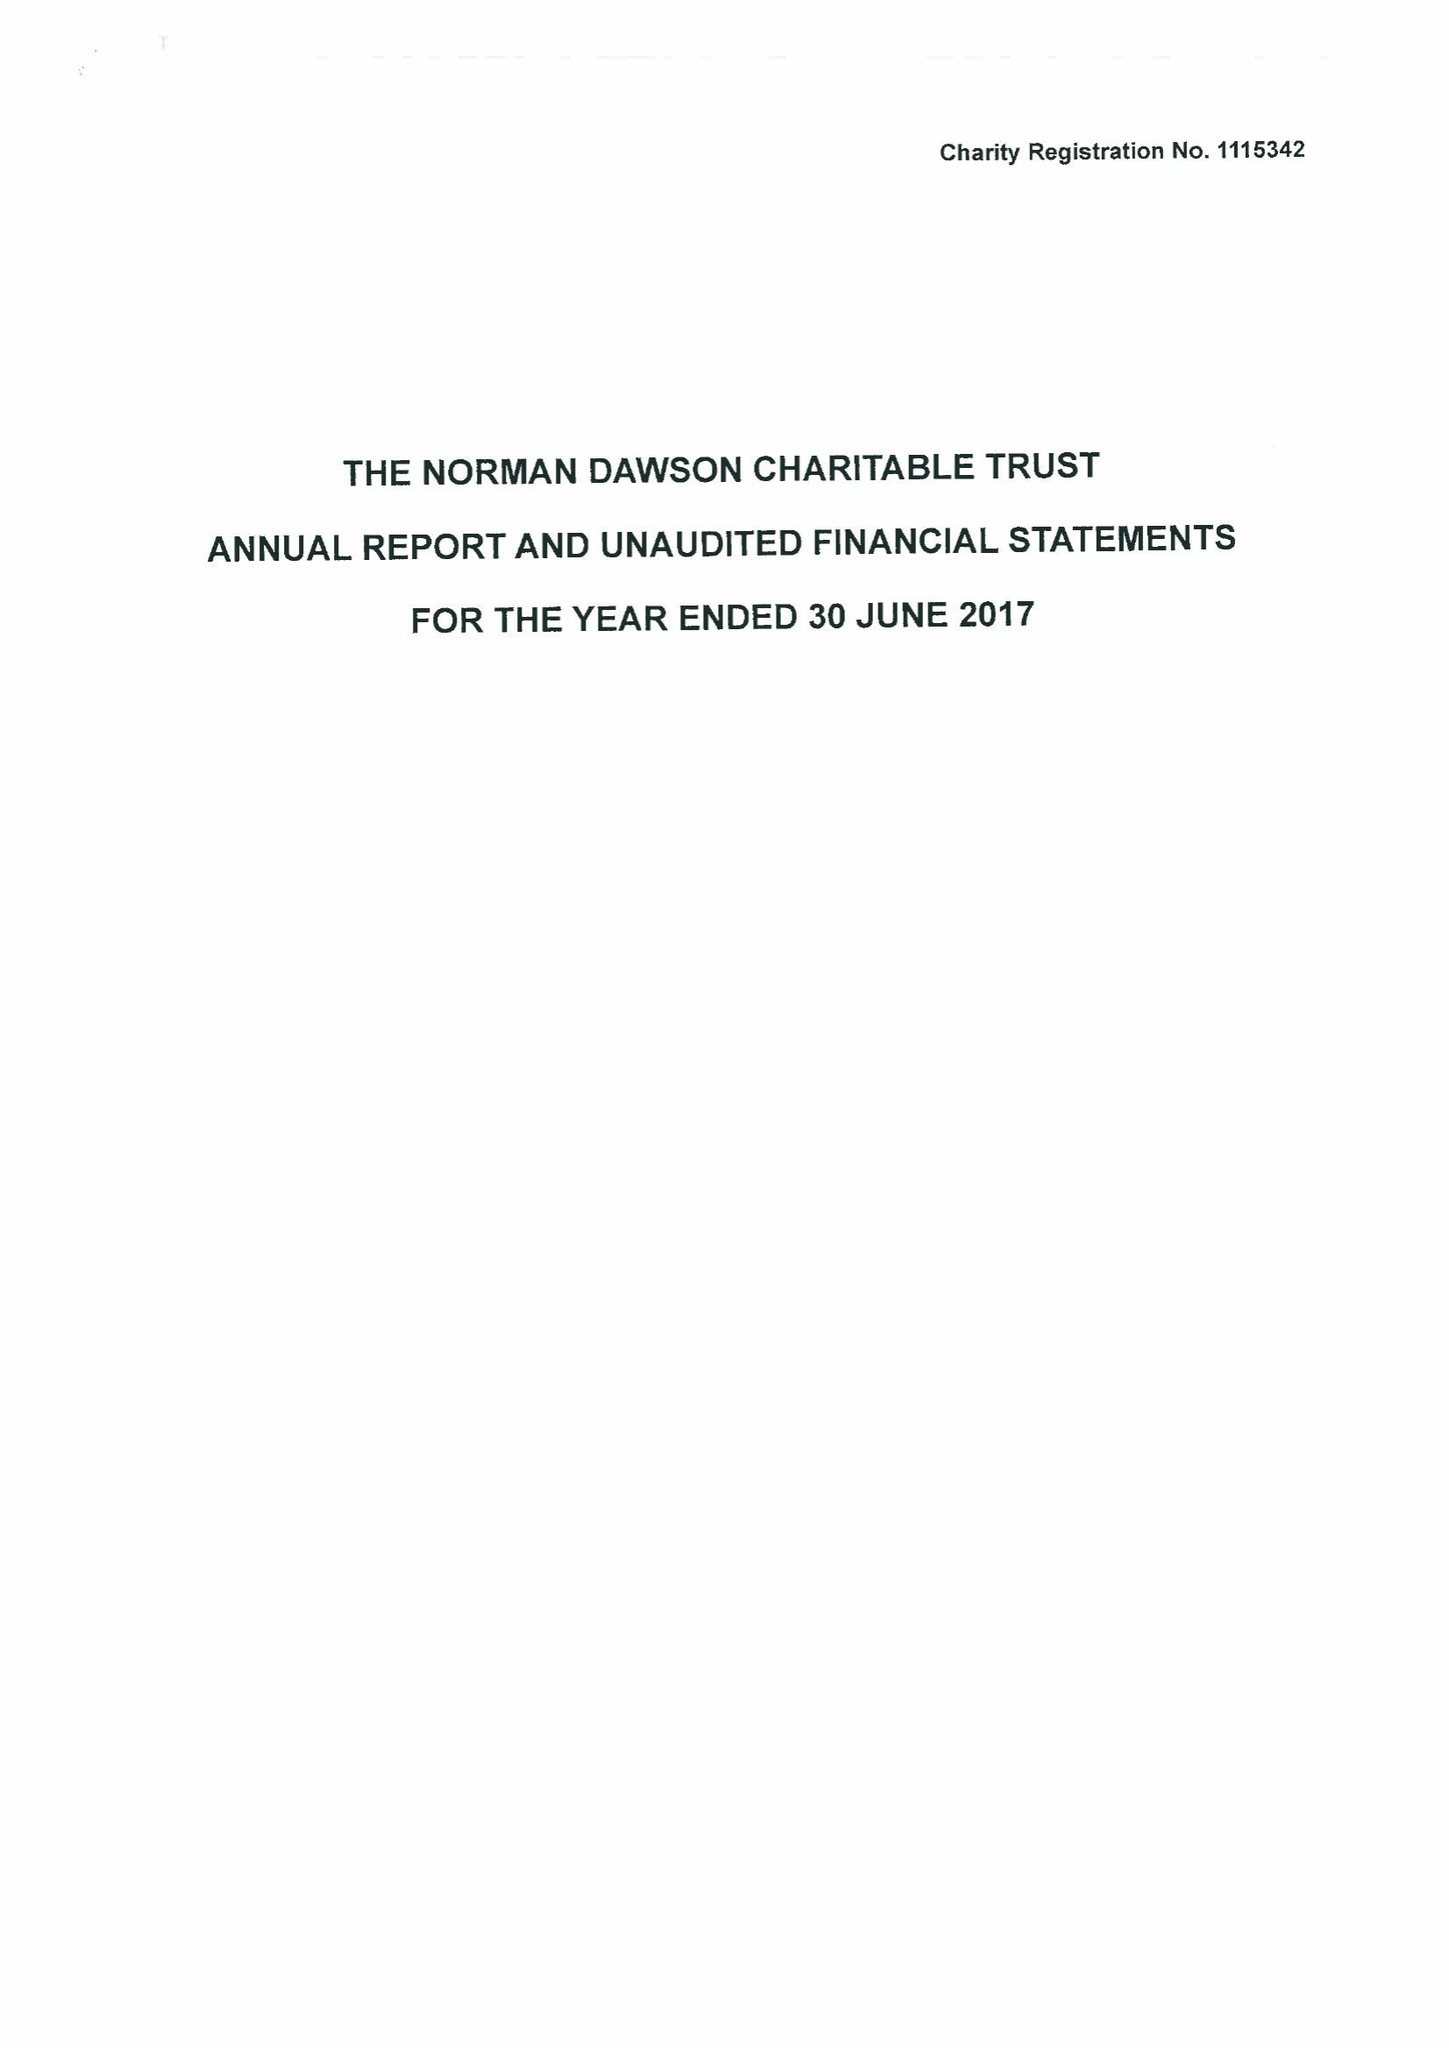What is the value for the income_annually_in_british_pounds?
Answer the question using a single word or phrase. 43506.00 